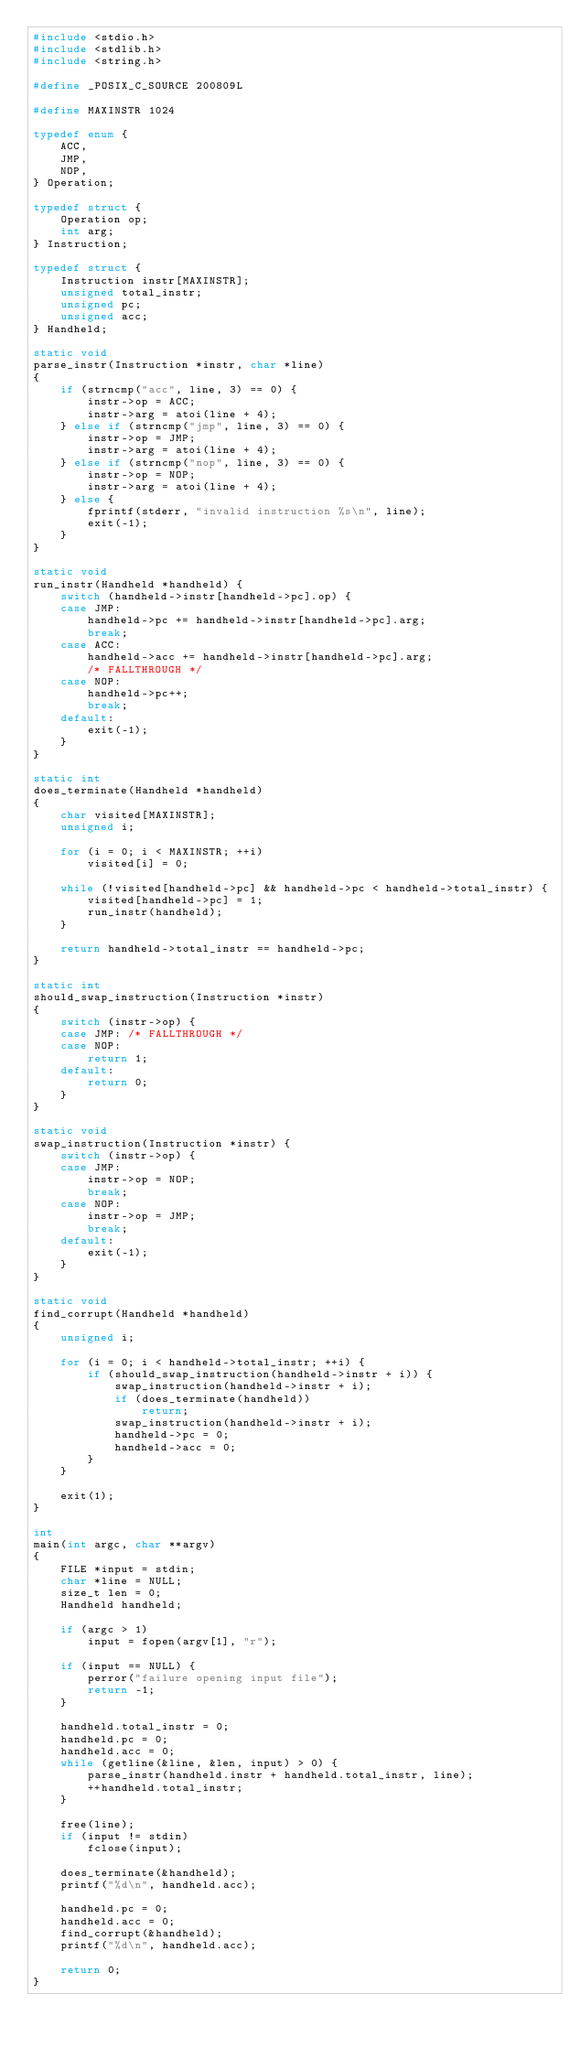Convert code to text. <code><loc_0><loc_0><loc_500><loc_500><_C_>#include <stdio.h>
#include <stdlib.h>
#include <string.h>

#define _POSIX_C_SOURCE 200809L

#define MAXINSTR 1024

typedef enum {
	ACC,
	JMP,
	NOP,
} Operation;

typedef struct {
	Operation op;
	int arg;
} Instruction;

typedef struct {
	Instruction instr[MAXINSTR];
	unsigned total_instr;
	unsigned pc;
	unsigned acc;
} Handheld;

static void
parse_instr(Instruction *instr, char *line)
{
	if (strncmp("acc", line, 3) == 0) {
		instr->op = ACC;
		instr->arg = atoi(line + 4);
	} else if (strncmp("jmp", line, 3) == 0) {
		instr->op = JMP;
		instr->arg = atoi(line + 4);
	} else if (strncmp("nop", line, 3) == 0) {
		instr->op = NOP;
		instr->arg = atoi(line + 4);
	} else {
		fprintf(stderr, "invalid instruction %s\n", line);
		exit(-1);
	}
}

static void
run_instr(Handheld *handheld) {
	switch (handheld->instr[handheld->pc].op) {
	case JMP:
		handheld->pc += handheld->instr[handheld->pc].arg;
		break;
	case ACC:
		handheld->acc += handheld->instr[handheld->pc].arg;
		/* FALLTHROUGH */
	case NOP:
		handheld->pc++;
		break;
	default:
		exit(-1);
	}
}

static int
does_terminate(Handheld *handheld)
{
	char visited[MAXINSTR];
	unsigned i;

	for (i = 0; i < MAXINSTR; ++i)
		visited[i] = 0;

	while (!visited[handheld->pc] && handheld->pc < handheld->total_instr) {
		visited[handheld->pc] = 1;
		run_instr(handheld);
	}

	return handheld->total_instr == handheld->pc;
}

static int
should_swap_instruction(Instruction *instr)
{
	switch (instr->op) {
	case JMP: /* FALLTHROUGH */
	case NOP:
		return 1;
	default:
		return 0;
	}
}

static void
swap_instruction(Instruction *instr) {
	switch (instr->op) {
	case JMP:
		instr->op = NOP;
		break;
	case NOP:
		instr->op = JMP;
		break;
	default:
		exit(-1);
	}
}

static void
find_corrupt(Handheld *handheld)
{
	unsigned i;

	for (i = 0; i < handheld->total_instr; ++i) {
		if (should_swap_instruction(handheld->instr + i)) {
			swap_instruction(handheld->instr + i);
			if (does_terminate(handheld))
				return;
			swap_instruction(handheld->instr + i);
			handheld->pc = 0;
			handheld->acc = 0;
		}
	}

	exit(1);
}

int
main(int argc, char **argv)
{
	FILE *input = stdin;
	char *line = NULL;
	size_t len = 0;
	Handheld handheld;

	if (argc > 1)
		input = fopen(argv[1], "r");

	if (input == NULL) {
		perror("failure opening input file");
		return -1;
	}

	handheld.total_instr = 0;
	handheld.pc = 0;
	handheld.acc = 0;
	while (getline(&line, &len, input) > 0) {
		parse_instr(handheld.instr + handheld.total_instr, line);
		++handheld.total_instr;
	}

	free(line);
	if (input != stdin)
		fclose(input);

	does_terminate(&handheld);
	printf("%d\n", handheld.acc);

	handheld.pc = 0;
	handheld.acc = 0;
	find_corrupt(&handheld);
	printf("%d\n", handheld.acc);

	return 0;
}
</code> 